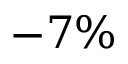<formula> <loc_0><loc_0><loc_500><loc_500>- 7 \%</formula> 